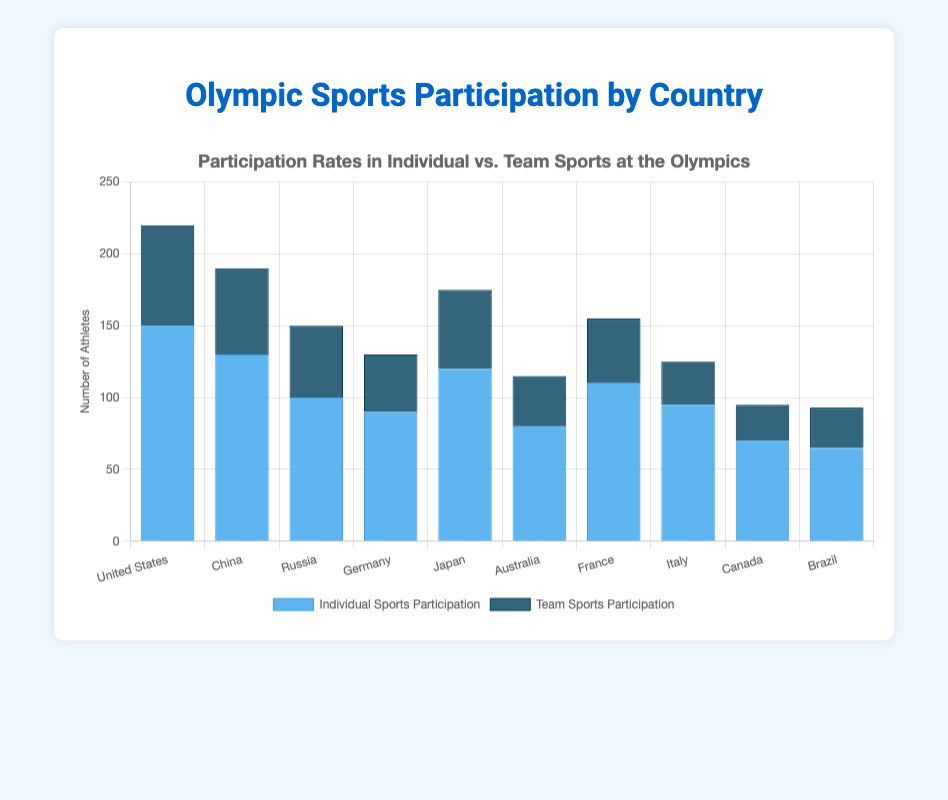Which country has the highest participation in individual sports? Look at the height of the blue bars in the chart for individual sports participation. The United States has the tallest blue bar, indicating the highest participation.
Answer: United States Which country has the lowest participation in team sports? Look at the height of the dark blue bars in the chart for team sports participation. Canada has the shortest dark blue bar, indicating the lowest participation.
Answer: Canada What is the total participation of Brazil in both individual and team sports? Sum the values for individual and team sports participation for Brazil. Individual sports: 65, team sports: 28. The total is 65 + 28.
Answer: 93 How many more athletes does Germany have in individual sports compared to team sports? Look at Germany’s participation numbers. Individual sports: 90, team sports: 40. Subtract the team sports participation from individual sports participation: 90 - 40 = 50.
Answer: 50 Which country has a higher participation in team sports, France or Australia? Compare the dark blue bars for France and Australia. France has a higher team sports participation with a value of 45 compared to Australia’s 35.
Answer: France What is the average participation in individual sports for the top 3 countries in individual sports participation? Identify the top 3 countries in individual sports participation: United States (150), China (130), and Japan (120). Compute the average: (150 + 130 + 120) / 3 = 400 / 3.
Answer: 133.33 Which countries have more athletes participating in individual sports than team sports? Compare the heights of the blue and dark blue bars for each country. All countries have higher participation in individual sports than team sports.
Answer: All countries What is the difference in total participation (individual + team) between United States and Canada? Calculate the total participation for both countries. United States: 150 + 70 = 220, Canada: 70 + 25 = 95. Subtract Canada's total from the United States' total: 220 - 95.
Answer: 125 How many athletes participate in team sports in the top two countries with the highest total participation? Identify the top two countries: United States (220), China (190). Sum their team sports participation: United States (70) + China (60).
Answer: 130 